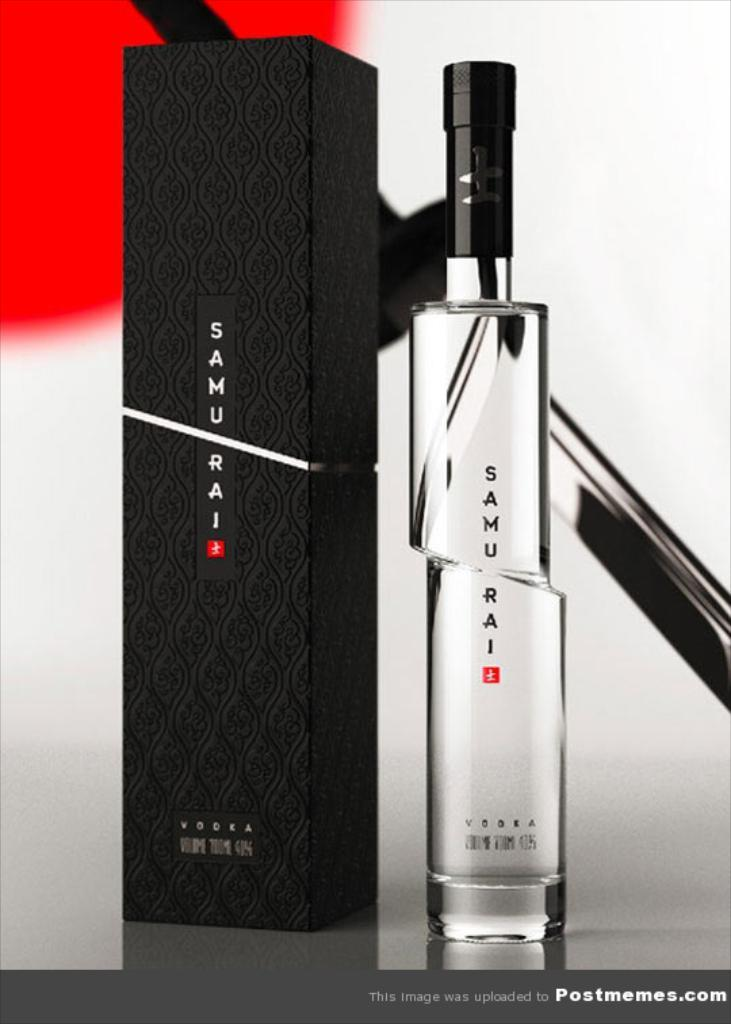<image>
Create a compact narrative representing the image presented. A cologne in a tall thin bottle is Samurai brand. 